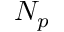Convert formula to latex. <formula><loc_0><loc_0><loc_500><loc_500>N _ { p }</formula> 